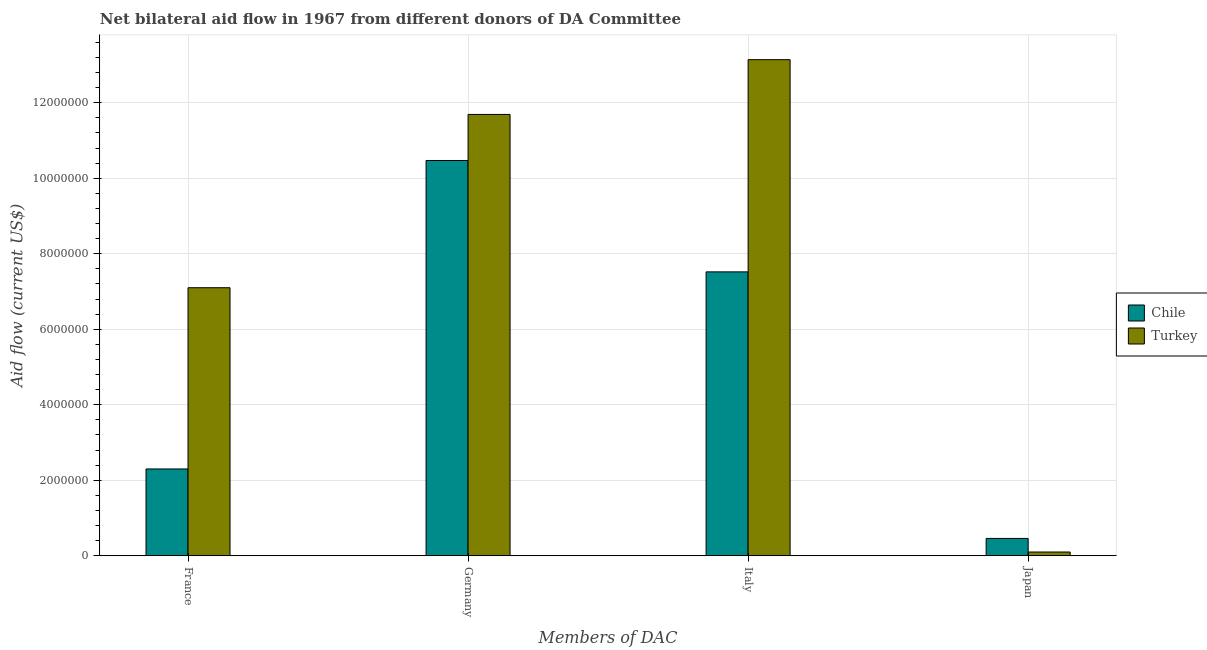What is the amount of aid given by france in Chile?
Make the answer very short. 2.30e+06. Across all countries, what is the maximum amount of aid given by italy?
Keep it short and to the point. 1.31e+07. Across all countries, what is the minimum amount of aid given by italy?
Keep it short and to the point. 7.52e+06. In which country was the amount of aid given by japan maximum?
Make the answer very short. Chile. What is the total amount of aid given by france in the graph?
Keep it short and to the point. 9.40e+06. What is the difference between the amount of aid given by italy in Chile and that in Turkey?
Give a very brief answer. -5.62e+06. What is the difference between the amount of aid given by italy in Chile and the amount of aid given by japan in Turkey?
Provide a short and direct response. 7.42e+06. What is the difference between the amount of aid given by france and amount of aid given by germany in Turkey?
Your answer should be compact. -4.59e+06. What is the ratio of the amount of aid given by italy in Turkey to that in Chile?
Your response must be concise. 1.75. What is the difference between the highest and the second highest amount of aid given by germany?
Give a very brief answer. 1.22e+06. What is the difference between the highest and the lowest amount of aid given by france?
Your answer should be very brief. 4.80e+06. Is it the case that in every country, the sum of the amount of aid given by germany and amount of aid given by japan is greater than the sum of amount of aid given by france and amount of aid given by italy?
Make the answer very short. No. Is it the case that in every country, the sum of the amount of aid given by france and amount of aid given by germany is greater than the amount of aid given by italy?
Your answer should be very brief. Yes. Are all the bars in the graph horizontal?
Provide a succinct answer. No. How many countries are there in the graph?
Your response must be concise. 2. How many legend labels are there?
Your response must be concise. 2. How are the legend labels stacked?
Provide a succinct answer. Vertical. What is the title of the graph?
Offer a terse response. Net bilateral aid flow in 1967 from different donors of DA Committee. What is the label or title of the X-axis?
Provide a short and direct response. Members of DAC. What is the Aid flow (current US$) in Chile in France?
Your answer should be compact. 2.30e+06. What is the Aid flow (current US$) of Turkey in France?
Ensure brevity in your answer.  7.10e+06. What is the Aid flow (current US$) of Chile in Germany?
Give a very brief answer. 1.05e+07. What is the Aid flow (current US$) of Turkey in Germany?
Make the answer very short. 1.17e+07. What is the Aid flow (current US$) in Chile in Italy?
Make the answer very short. 7.52e+06. What is the Aid flow (current US$) in Turkey in Italy?
Your answer should be compact. 1.31e+07. What is the Aid flow (current US$) of Chile in Japan?
Offer a terse response. 4.60e+05. What is the Aid flow (current US$) of Turkey in Japan?
Provide a succinct answer. 1.00e+05. Across all Members of DAC, what is the maximum Aid flow (current US$) in Chile?
Give a very brief answer. 1.05e+07. Across all Members of DAC, what is the maximum Aid flow (current US$) of Turkey?
Your response must be concise. 1.31e+07. Across all Members of DAC, what is the minimum Aid flow (current US$) in Chile?
Your answer should be very brief. 4.60e+05. Across all Members of DAC, what is the minimum Aid flow (current US$) in Turkey?
Keep it short and to the point. 1.00e+05. What is the total Aid flow (current US$) in Chile in the graph?
Ensure brevity in your answer.  2.08e+07. What is the total Aid flow (current US$) of Turkey in the graph?
Keep it short and to the point. 3.20e+07. What is the difference between the Aid flow (current US$) of Chile in France and that in Germany?
Your answer should be compact. -8.17e+06. What is the difference between the Aid flow (current US$) in Turkey in France and that in Germany?
Make the answer very short. -4.59e+06. What is the difference between the Aid flow (current US$) of Chile in France and that in Italy?
Provide a short and direct response. -5.22e+06. What is the difference between the Aid flow (current US$) in Turkey in France and that in Italy?
Offer a very short reply. -6.04e+06. What is the difference between the Aid flow (current US$) in Chile in France and that in Japan?
Your response must be concise. 1.84e+06. What is the difference between the Aid flow (current US$) in Chile in Germany and that in Italy?
Offer a terse response. 2.95e+06. What is the difference between the Aid flow (current US$) in Turkey in Germany and that in Italy?
Make the answer very short. -1.45e+06. What is the difference between the Aid flow (current US$) in Chile in Germany and that in Japan?
Offer a very short reply. 1.00e+07. What is the difference between the Aid flow (current US$) of Turkey in Germany and that in Japan?
Your response must be concise. 1.16e+07. What is the difference between the Aid flow (current US$) of Chile in Italy and that in Japan?
Give a very brief answer. 7.06e+06. What is the difference between the Aid flow (current US$) of Turkey in Italy and that in Japan?
Your answer should be compact. 1.30e+07. What is the difference between the Aid flow (current US$) of Chile in France and the Aid flow (current US$) of Turkey in Germany?
Your response must be concise. -9.39e+06. What is the difference between the Aid flow (current US$) in Chile in France and the Aid flow (current US$) in Turkey in Italy?
Provide a short and direct response. -1.08e+07. What is the difference between the Aid flow (current US$) in Chile in France and the Aid flow (current US$) in Turkey in Japan?
Offer a terse response. 2.20e+06. What is the difference between the Aid flow (current US$) in Chile in Germany and the Aid flow (current US$) in Turkey in Italy?
Your response must be concise. -2.67e+06. What is the difference between the Aid flow (current US$) in Chile in Germany and the Aid flow (current US$) in Turkey in Japan?
Make the answer very short. 1.04e+07. What is the difference between the Aid flow (current US$) in Chile in Italy and the Aid flow (current US$) in Turkey in Japan?
Your response must be concise. 7.42e+06. What is the average Aid flow (current US$) in Chile per Members of DAC?
Your response must be concise. 5.19e+06. What is the average Aid flow (current US$) of Turkey per Members of DAC?
Ensure brevity in your answer.  8.01e+06. What is the difference between the Aid flow (current US$) of Chile and Aid flow (current US$) of Turkey in France?
Ensure brevity in your answer.  -4.80e+06. What is the difference between the Aid flow (current US$) in Chile and Aid flow (current US$) in Turkey in Germany?
Keep it short and to the point. -1.22e+06. What is the difference between the Aid flow (current US$) in Chile and Aid flow (current US$) in Turkey in Italy?
Your answer should be compact. -5.62e+06. What is the difference between the Aid flow (current US$) of Chile and Aid flow (current US$) of Turkey in Japan?
Offer a terse response. 3.60e+05. What is the ratio of the Aid flow (current US$) in Chile in France to that in Germany?
Your response must be concise. 0.22. What is the ratio of the Aid flow (current US$) in Turkey in France to that in Germany?
Your answer should be very brief. 0.61. What is the ratio of the Aid flow (current US$) of Chile in France to that in Italy?
Make the answer very short. 0.31. What is the ratio of the Aid flow (current US$) of Turkey in France to that in Italy?
Ensure brevity in your answer.  0.54. What is the ratio of the Aid flow (current US$) of Turkey in France to that in Japan?
Your response must be concise. 71. What is the ratio of the Aid flow (current US$) in Chile in Germany to that in Italy?
Offer a terse response. 1.39. What is the ratio of the Aid flow (current US$) in Turkey in Germany to that in Italy?
Offer a very short reply. 0.89. What is the ratio of the Aid flow (current US$) in Chile in Germany to that in Japan?
Ensure brevity in your answer.  22.76. What is the ratio of the Aid flow (current US$) of Turkey in Germany to that in Japan?
Your response must be concise. 116.9. What is the ratio of the Aid flow (current US$) in Chile in Italy to that in Japan?
Give a very brief answer. 16.35. What is the ratio of the Aid flow (current US$) of Turkey in Italy to that in Japan?
Ensure brevity in your answer.  131.4. What is the difference between the highest and the second highest Aid flow (current US$) in Chile?
Offer a terse response. 2.95e+06. What is the difference between the highest and the second highest Aid flow (current US$) of Turkey?
Provide a succinct answer. 1.45e+06. What is the difference between the highest and the lowest Aid flow (current US$) of Chile?
Ensure brevity in your answer.  1.00e+07. What is the difference between the highest and the lowest Aid flow (current US$) in Turkey?
Ensure brevity in your answer.  1.30e+07. 